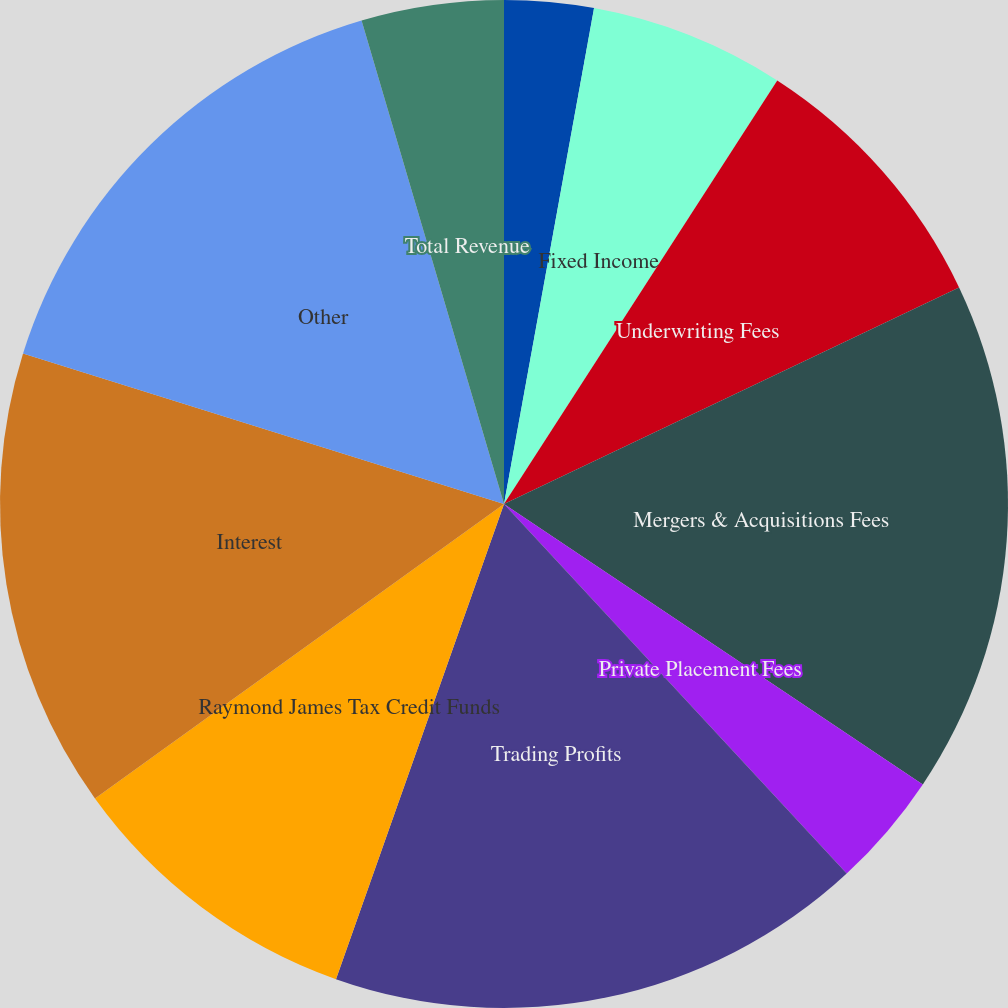Convert chart. <chart><loc_0><loc_0><loc_500><loc_500><pie_chart><fcel>Equity<fcel>Fixed Income<fcel>Underwriting Fees<fcel>Mergers & Acquisitions Fees<fcel>Private Placement Fees<fcel>Trading Profits<fcel>Raymond James Tax Credit Funds<fcel>Interest<fcel>Other<fcel>Total Revenue<nl><fcel>2.86%<fcel>6.26%<fcel>8.81%<fcel>16.46%<fcel>3.71%<fcel>17.31%<fcel>9.66%<fcel>14.76%<fcel>15.61%<fcel>4.56%<nl></chart> 